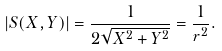<formula> <loc_0><loc_0><loc_500><loc_500>| S ( X , Y ) | = \frac { 1 } { 2 \sqrt { X ^ { 2 } + Y ^ { 2 } } } = \frac { 1 } { r ^ { 2 } } .</formula> 